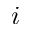<formula> <loc_0><loc_0><loc_500><loc_500>i</formula> 